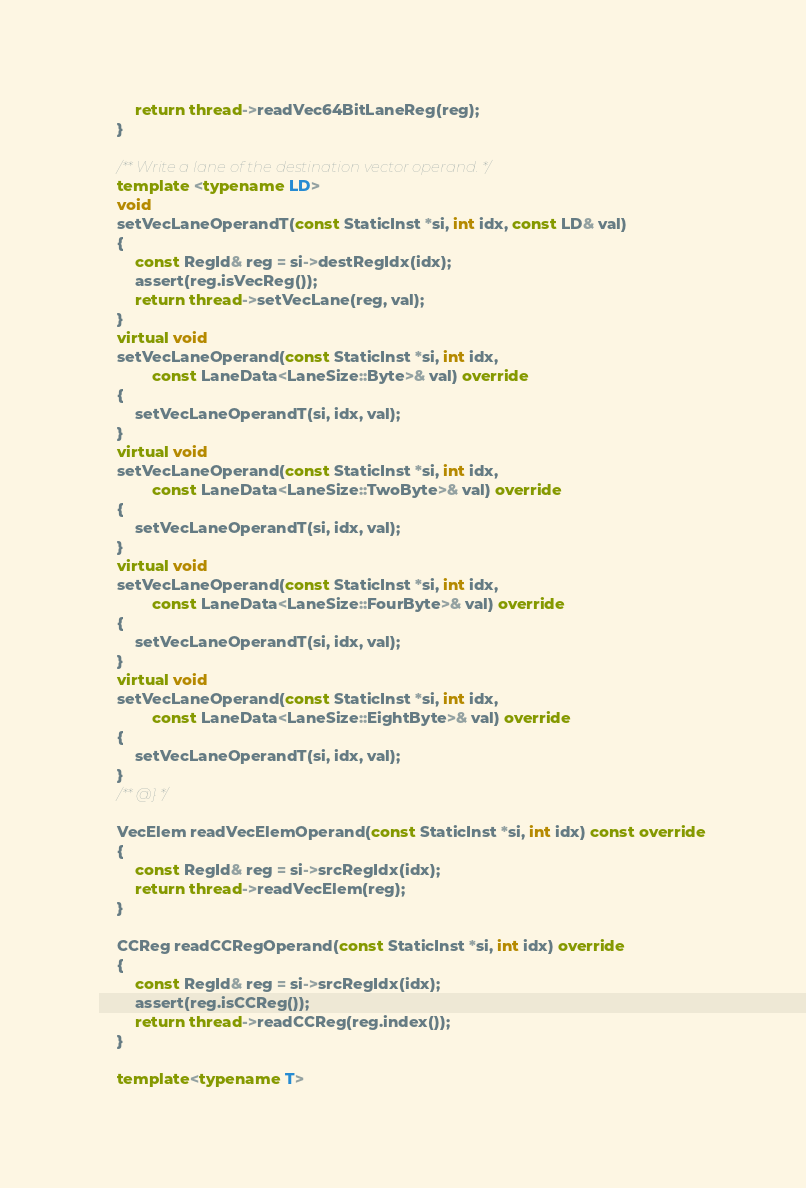Convert code to text. <code><loc_0><loc_0><loc_500><loc_500><_C++_>        return thread->readVec64BitLaneReg(reg);
    }

    /** Write a lane of the destination vector operand. */
    template <typename LD>
    void
    setVecLaneOperandT(const StaticInst *si, int idx, const LD& val)
    {
        const RegId& reg = si->destRegIdx(idx);
        assert(reg.isVecReg());
        return thread->setVecLane(reg, val);
    }
    virtual void
    setVecLaneOperand(const StaticInst *si, int idx,
            const LaneData<LaneSize::Byte>& val) override
    {
        setVecLaneOperandT(si, idx, val);
    }
    virtual void
    setVecLaneOperand(const StaticInst *si, int idx,
            const LaneData<LaneSize::TwoByte>& val) override
    {
        setVecLaneOperandT(si, idx, val);
    }
    virtual void
    setVecLaneOperand(const StaticInst *si, int idx,
            const LaneData<LaneSize::FourByte>& val) override
    {
        setVecLaneOperandT(si, idx, val);
    }
    virtual void
    setVecLaneOperand(const StaticInst *si, int idx,
            const LaneData<LaneSize::EightByte>& val) override
    {
        setVecLaneOperandT(si, idx, val);
    }
    /** @} */

    VecElem readVecElemOperand(const StaticInst *si, int idx) const override
    {
        const RegId& reg = si->srcRegIdx(idx);
        return thread->readVecElem(reg);
    }

    CCReg readCCRegOperand(const StaticInst *si, int idx) override
    {
        const RegId& reg = si->srcRegIdx(idx);
        assert(reg.isCCReg());
        return thread->readCCReg(reg.index());
    }

    template<typename T></code> 